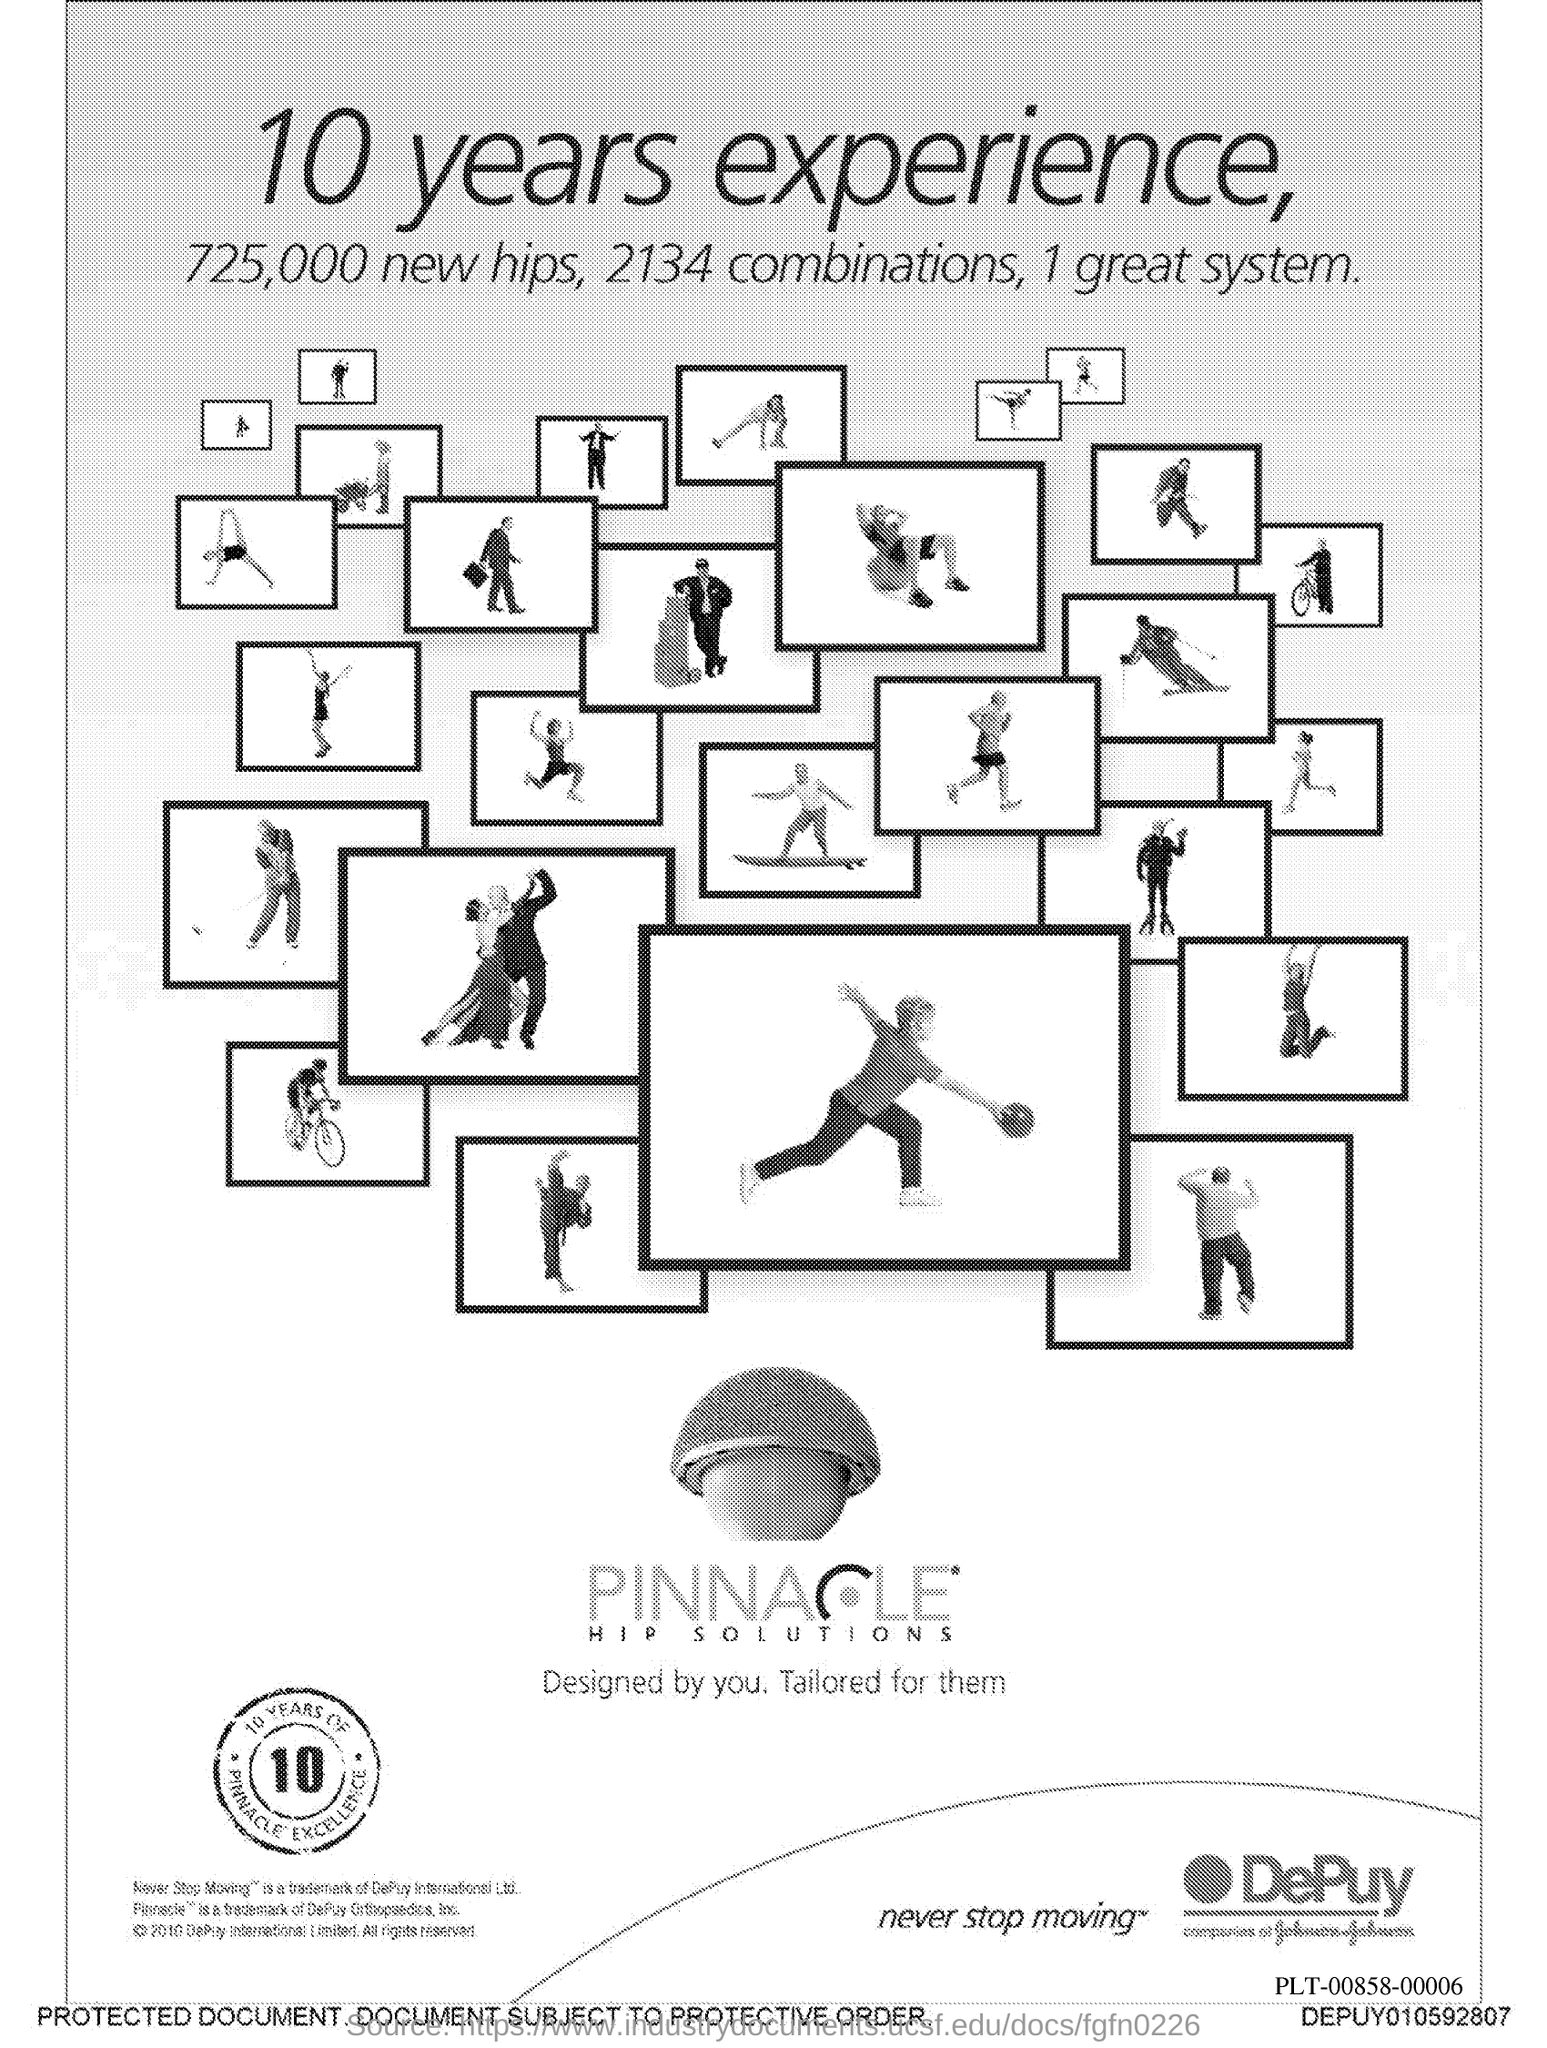Indicate a few pertinent items in this graphic. The number in zeal is 10. 